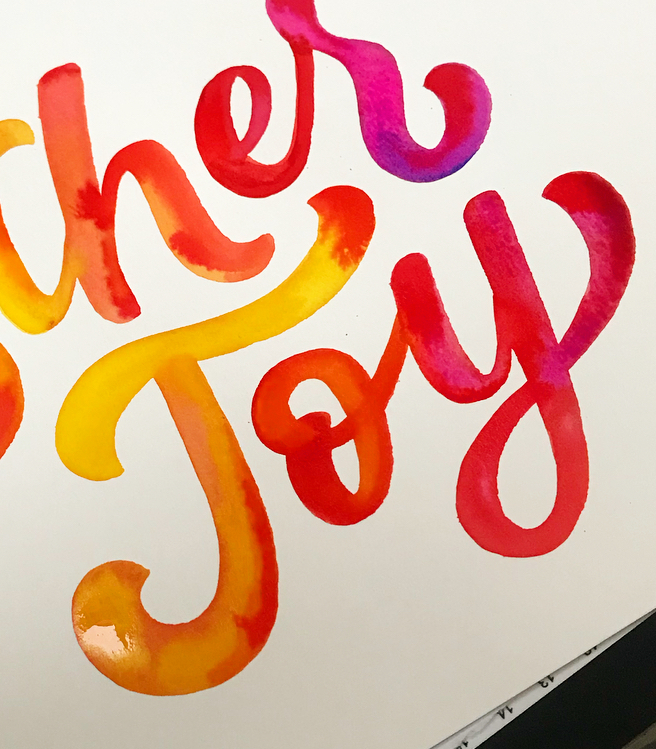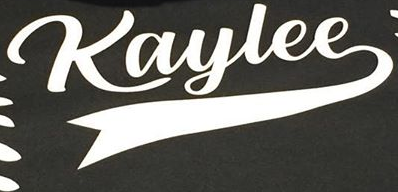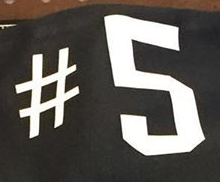Read the text from these images in sequence, separated by a semicolon. Joy; Kaylee; #5 